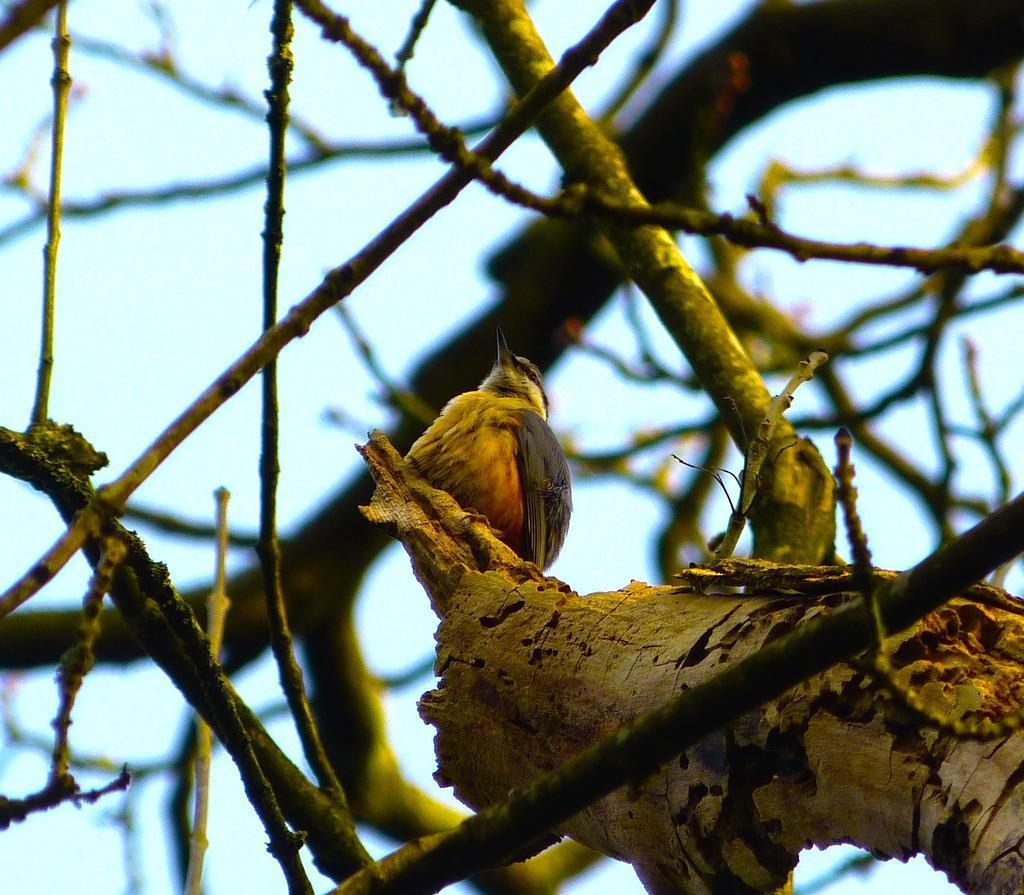Describe this image in one or two sentences. In this image there is a bird on the tree. 